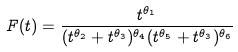Convert formula to latex. <formula><loc_0><loc_0><loc_500><loc_500>F ( t ) = \frac { t ^ { \theta _ { 1 } } } { ( t ^ { \theta _ { 2 } } + t ^ { \theta _ { 3 } } ) ^ { \theta _ { 4 } } ( t ^ { \theta _ { 5 } } + t ^ { \theta _ { 3 } } ) ^ { \theta _ { 6 } } }</formula> 